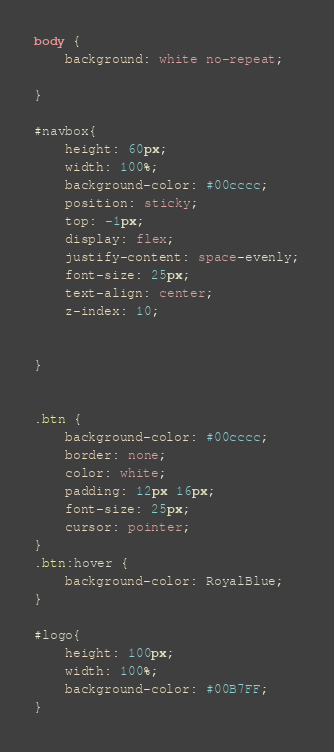Convert code to text. <code><loc_0><loc_0><loc_500><loc_500><_CSS_>body {
    background: white no-repeat;

}

#navbox{
    height: 60px;
    width: 100%;
    background-color: #00cccc;
    position: sticky;
    top: -1px;
    display: flex;
    justify-content: space-evenly;
    font-size: 25px;
    text-align: center;
    z-index: 10;


}


.btn {
    background-color: #00cccc;
    border: none;
    color: white;
    padding: 12px 16px;
    font-size: 25px;
    cursor: pointer;
}
.btn:hover {
    background-color: RoyalBlue;
}

#logo{
    height: 100px;
    width: 100%;
    background-color: #00B7FF;
}
</code> 